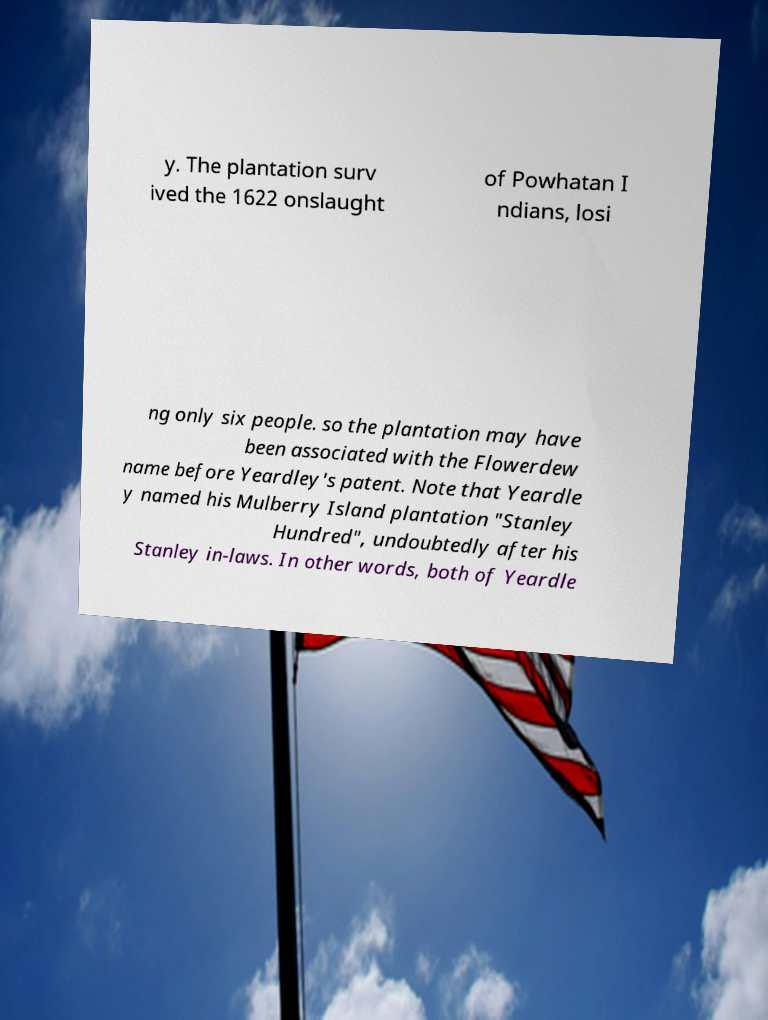What messages or text are displayed in this image? I need them in a readable, typed format. y. The plantation surv ived the 1622 onslaught of Powhatan I ndians, losi ng only six people. so the plantation may have been associated with the Flowerdew name before Yeardley's patent. Note that Yeardle y named his Mulberry Island plantation "Stanley Hundred", undoubtedly after his Stanley in-laws. In other words, both of Yeardle 